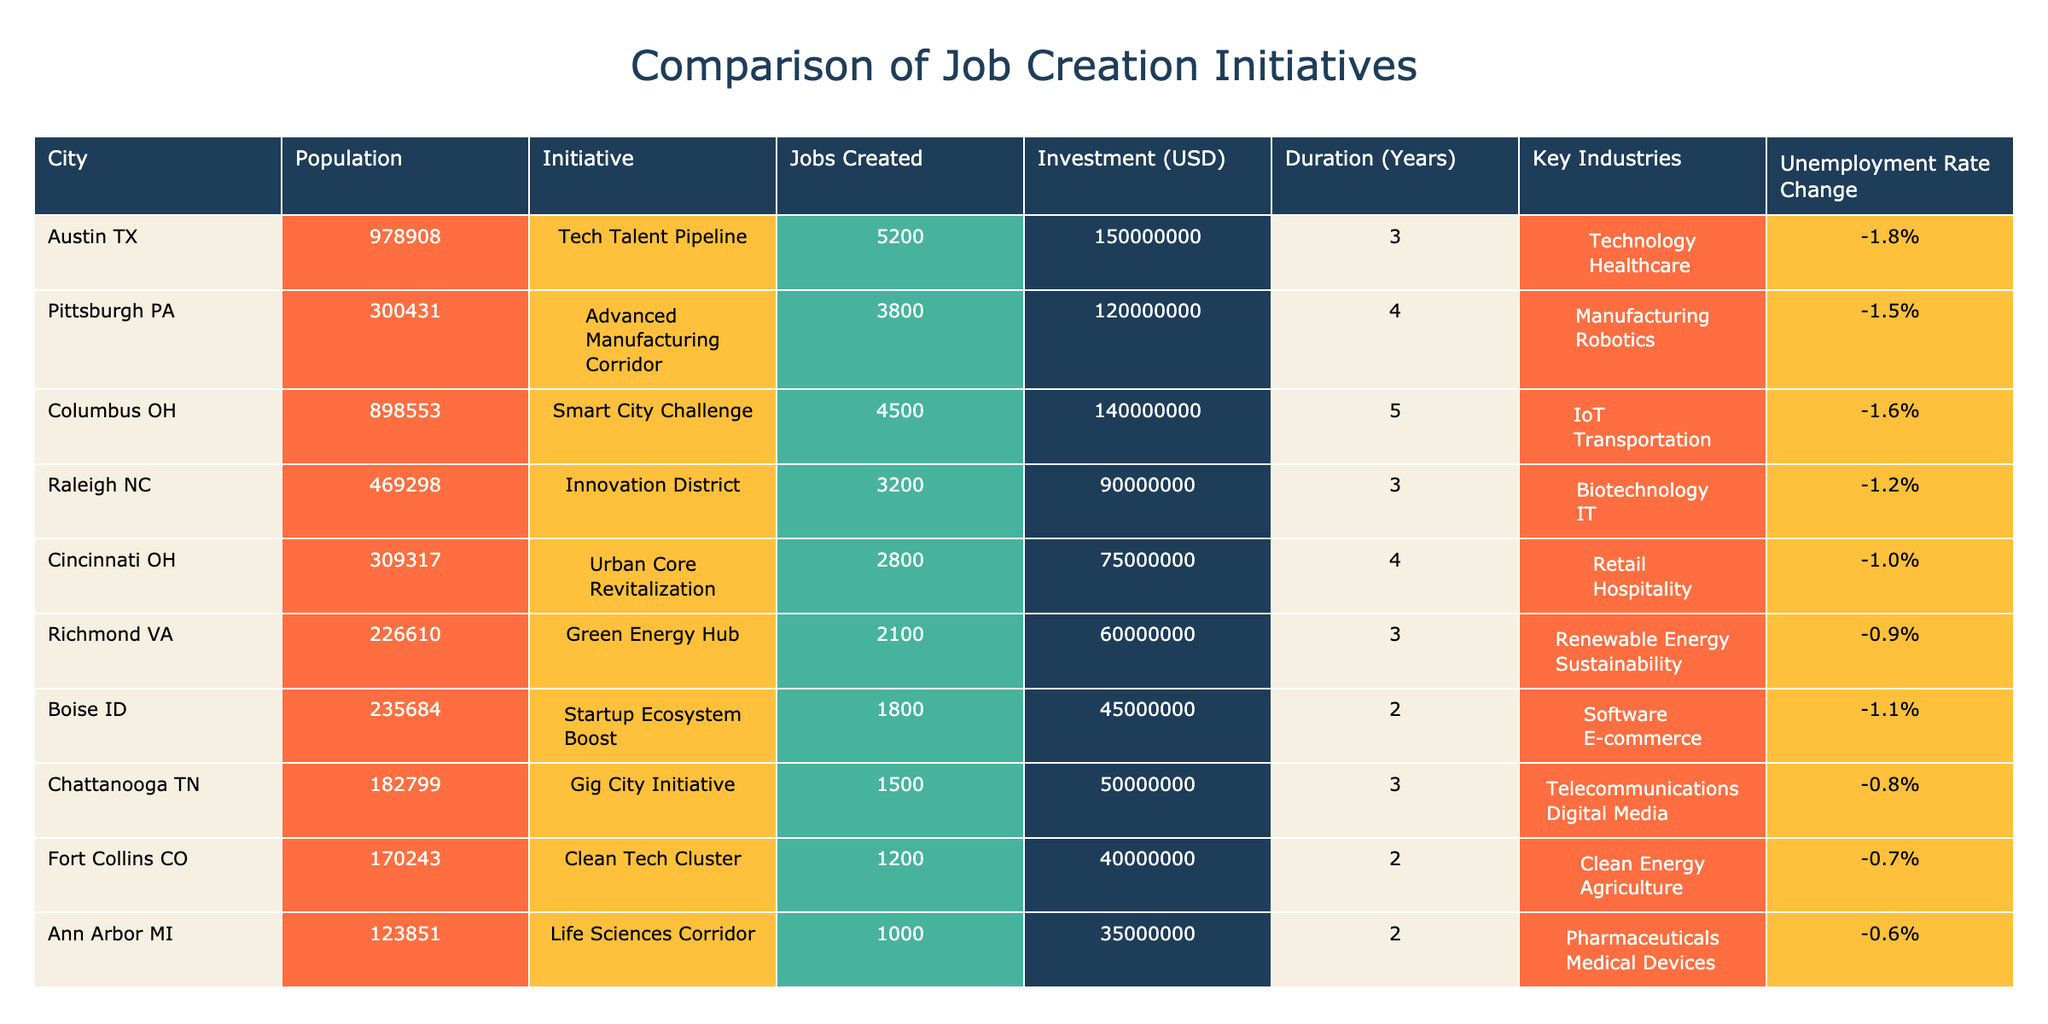What city has the highest number of jobs created? By reviewing the "Jobs Created" column in the table, Austin TX has the highest number with 5200 jobs.
Answer: Austin TX Which initiative had the lowest investment? Looking at the "Investment (USD)" column, the initiative with the lowest amount is the "Startup Ecosystem Boost" in Boise ID, which had an investment of 45000000 USD.
Answer: Startup Ecosystem Boost What is the average unemployment rate change across all initiatives? To find the average, sum all the changes: (-1.8% + -1.5% + -1.6% + -1.2% + -1.0% + -0.9% + -1.1% + -0.8% + -0.6%) = -10.5%. There are 9 initiatives, so the average is -10.5% / 9 ≈ -1.17%.
Answer: -1.17% Did any initiative result in an increase in the unemployment rate? Checking the "Unemployment Rate Change" column for positive values, all initiatives show a negative change, confirming none resulted in an increase.
Answer: No Which city's initiative had the longest duration and how many jobs did it create? By examining the "Duration (Years)" column, the longest duration is 5 years, attributed to the "Smart City Challenge" in Columbus OH, which created 4500 jobs.
Answer: Columbus OH, 4500 jobs 